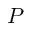<formula> <loc_0><loc_0><loc_500><loc_500>P</formula> 